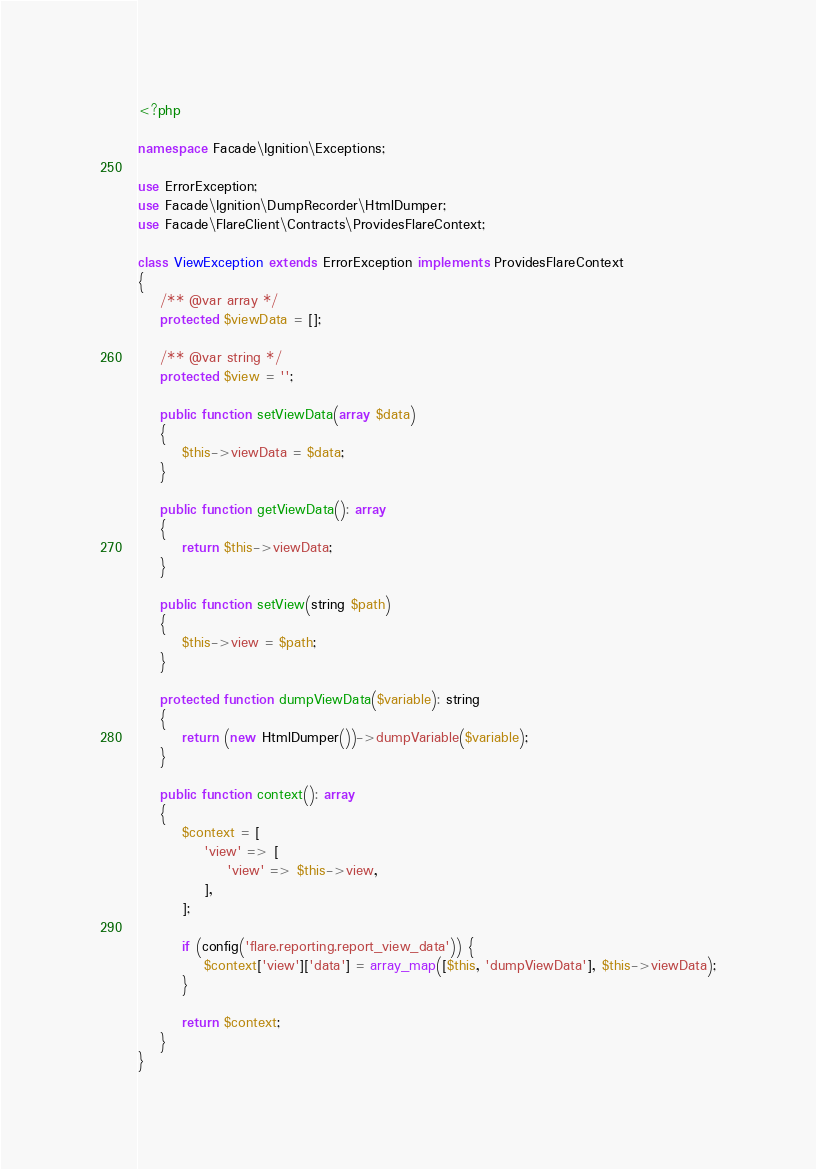<code> <loc_0><loc_0><loc_500><loc_500><_PHP_><?php

namespace Facade\Ignition\Exceptions;

use ErrorException;
use Facade\Ignition\DumpRecorder\HtmlDumper;
use Facade\FlareClient\Contracts\ProvidesFlareContext;

class ViewException extends ErrorException implements ProvidesFlareContext
{
    /** @var array */
    protected $viewData = [];

    /** @var string */
    protected $view = '';

    public function setViewData(array $data)
    {
        $this->viewData = $data;
    }

    public function getViewData(): array
    {
        return $this->viewData;
    }

    public function setView(string $path)
    {
        $this->view = $path;
    }

    protected function dumpViewData($variable): string
    {
        return (new HtmlDumper())->dumpVariable($variable);
    }

    public function context(): array
    {
        $context = [
            'view' => [
                'view' => $this->view,
            ],
        ];

        if (config('flare.reporting.report_view_data')) {
            $context['view']['data'] = array_map([$this, 'dumpViewData'], $this->viewData);
        }

        return $context;
    }
}
</code> 